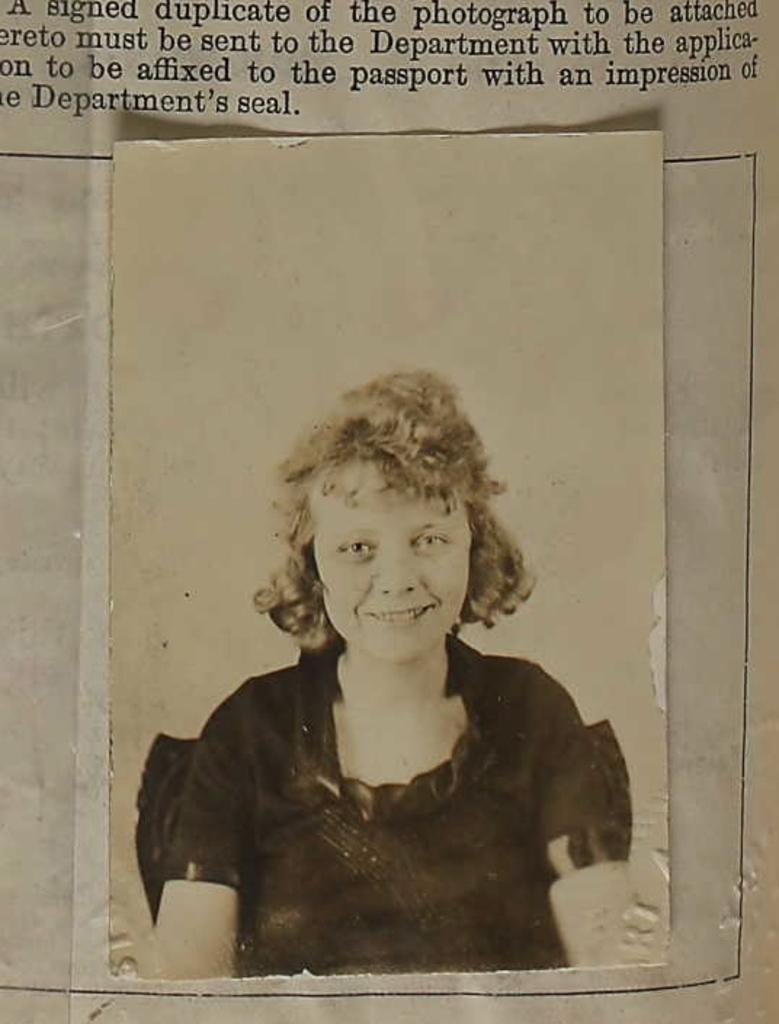What is present on the paper in the image? There is text on a paper in the image. Is there anything else attached to the paper? Yes, there is a photo of a person attached to the paper in the image. What language is the joke written in on the paper? There is no joke present on the paper in the image, so it cannot be determined what language it might be written in. 